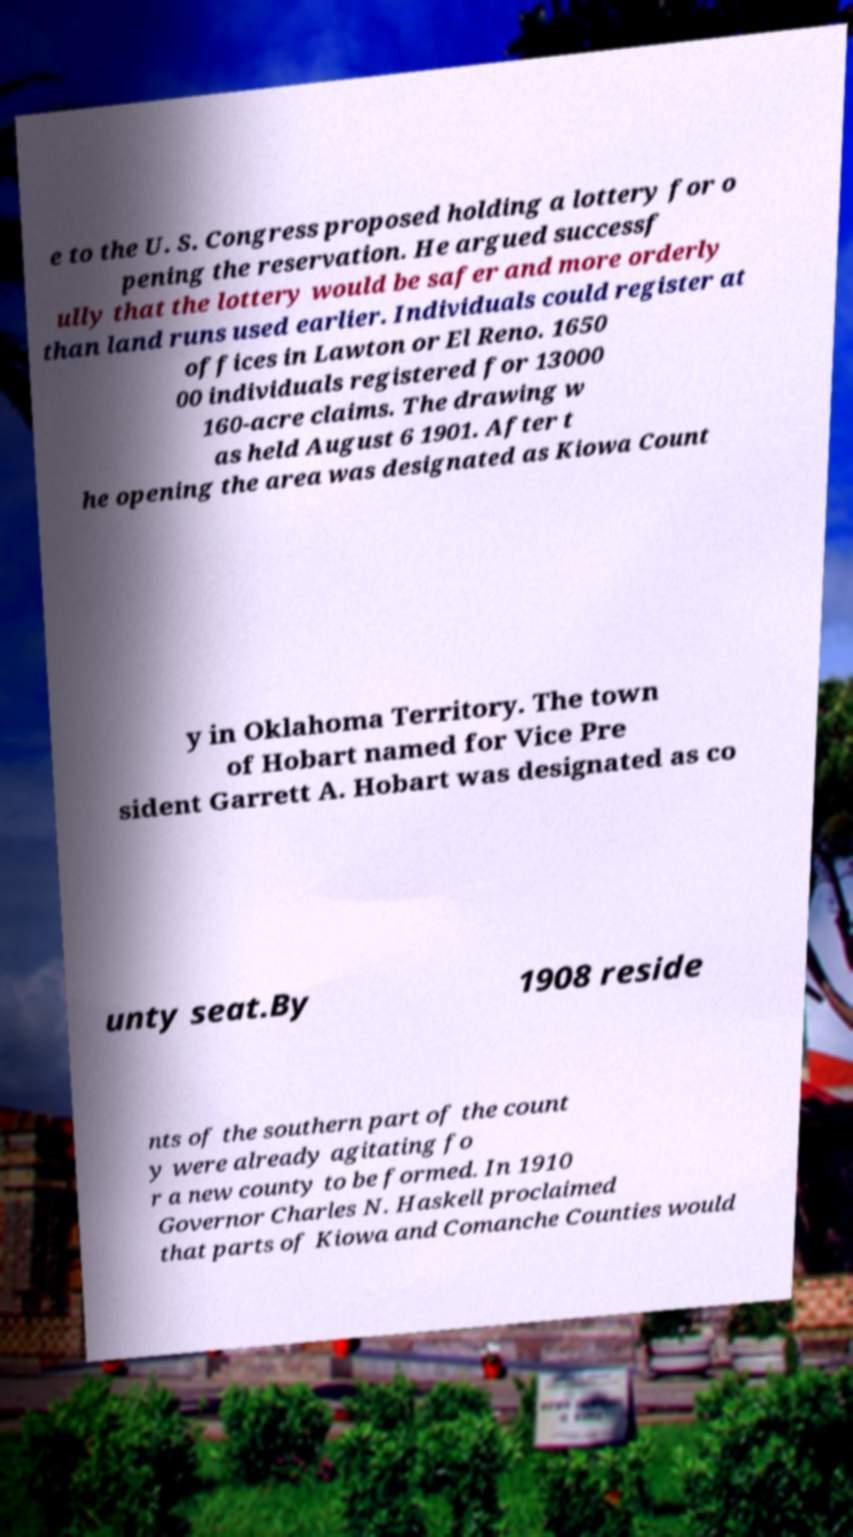Could you extract and type out the text from this image? e to the U. S. Congress proposed holding a lottery for o pening the reservation. He argued successf ully that the lottery would be safer and more orderly than land runs used earlier. Individuals could register at offices in Lawton or El Reno. 1650 00 individuals registered for 13000 160-acre claims. The drawing w as held August 6 1901. After t he opening the area was designated as Kiowa Count y in Oklahoma Territory. The town of Hobart named for Vice Pre sident Garrett A. Hobart was designated as co unty seat.By 1908 reside nts of the southern part of the count y were already agitating fo r a new county to be formed. In 1910 Governor Charles N. Haskell proclaimed that parts of Kiowa and Comanche Counties would 